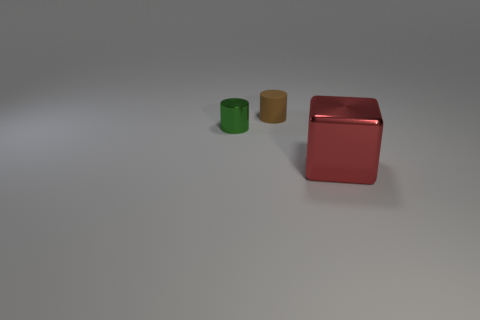Add 2 tiny green cylinders. How many objects exist? 5 Subtract all cylinders. How many objects are left? 1 Subtract 0 red cylinders. How many objects are left? 3 Subtract all tiny brown objects. Subtract all small matte cylinders. How many objects are left? 1 Add 2 green metal things. How many green metal things are left? 3 Add 2 small green shiny things. How many small green shiny things exist? 3 